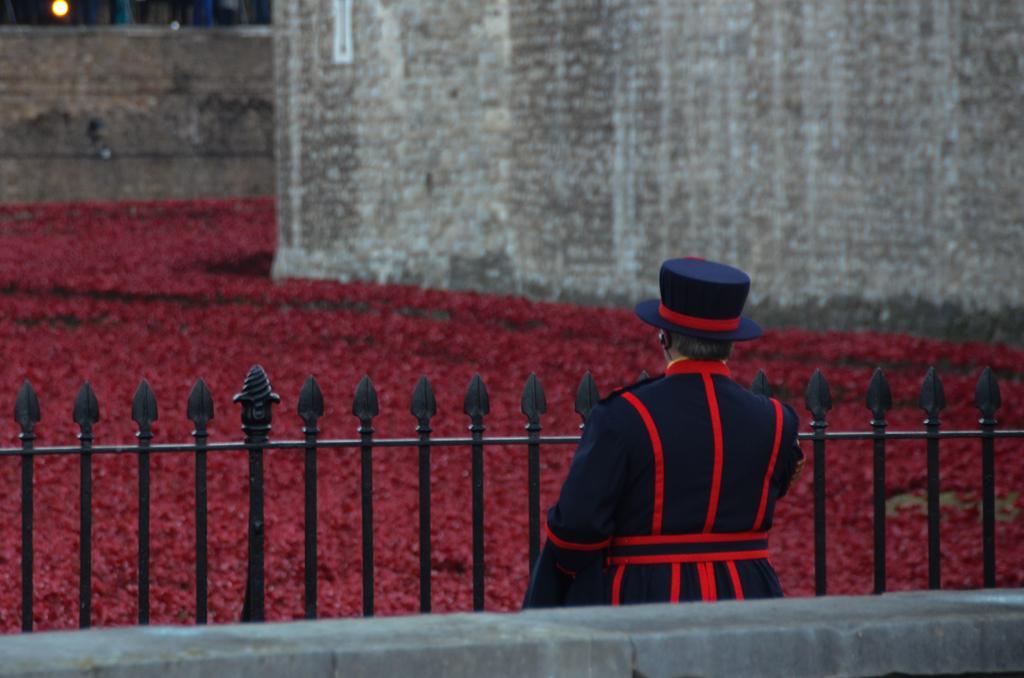In one or two sentences, can you explain what this image depicts? In this image we can see a man standing. He is wearing a uniform and there are grilles. In the background there are hedges and we can see walls. At the top there is a light. 